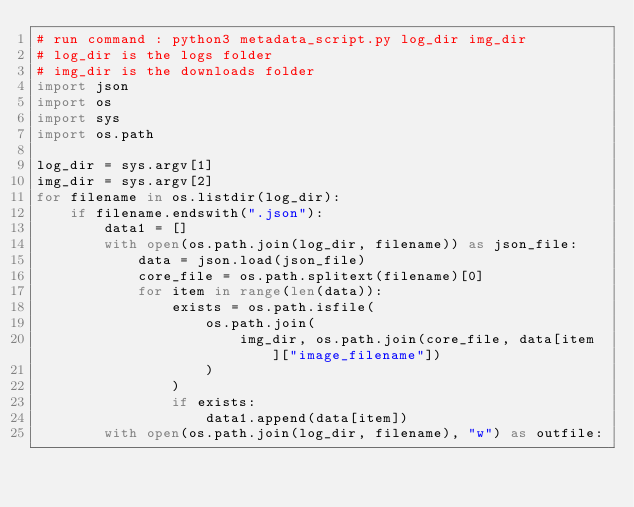<code> <loc_0><loc_0><loc_500><loc_500><_Python_># run command : python3 metadata_script.py log_dir img_dir
# log_dir is the logs folder
# img_dir is the downloads folder
import json
import os
import sys
import os.path

log_dir = sys.argv[1]
img_dir = sys.argv[2]
for filename in os.listdir(log_dir):
    if filename.endswith(".json"):
        data1 = []
        with open(os.path.join(log_dir, filename)) as json_file:
            data = json.load(json_file)
            core_file = os.path.splitext(filename)[0]
            for item in range(len(data)):
                exists = os.path.isfile(
                    os.path.join(
                        img_dir, os.path.join(core_file, data[item]["image_filename"])
                    )
                )
                if exists:
                    data1.append(data[item])
        with open(os.path.join(log_dir, filename), "w") as outfile:</code> 